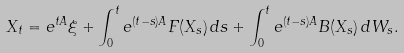<formula> <loc_0><loc_0><loc_500><loc_500>X _ { t } = e ^ { t A } \xi + \int _ { 0 } ^ { t } e ^ { ( t - s ) A } F ( X _ { s } ) \, d s + \int _ { 0 } ^ { t } e ^ { ( t - s ) A } B ( X _ { s } ) \, d W _ { s } .</formula> 